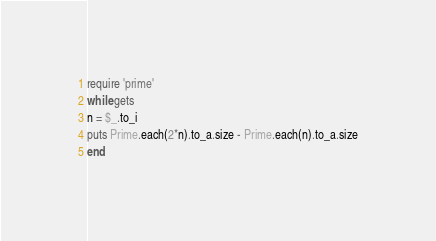Convert code to text. <code><loc_0><loc_0><loc_500><loc_500><_Ruby_>require 'prime'
while gets
n = $_.to_i
puts Prime.each(2*n).to_a.size - Prime.each(n).to_a.size
end</code> 